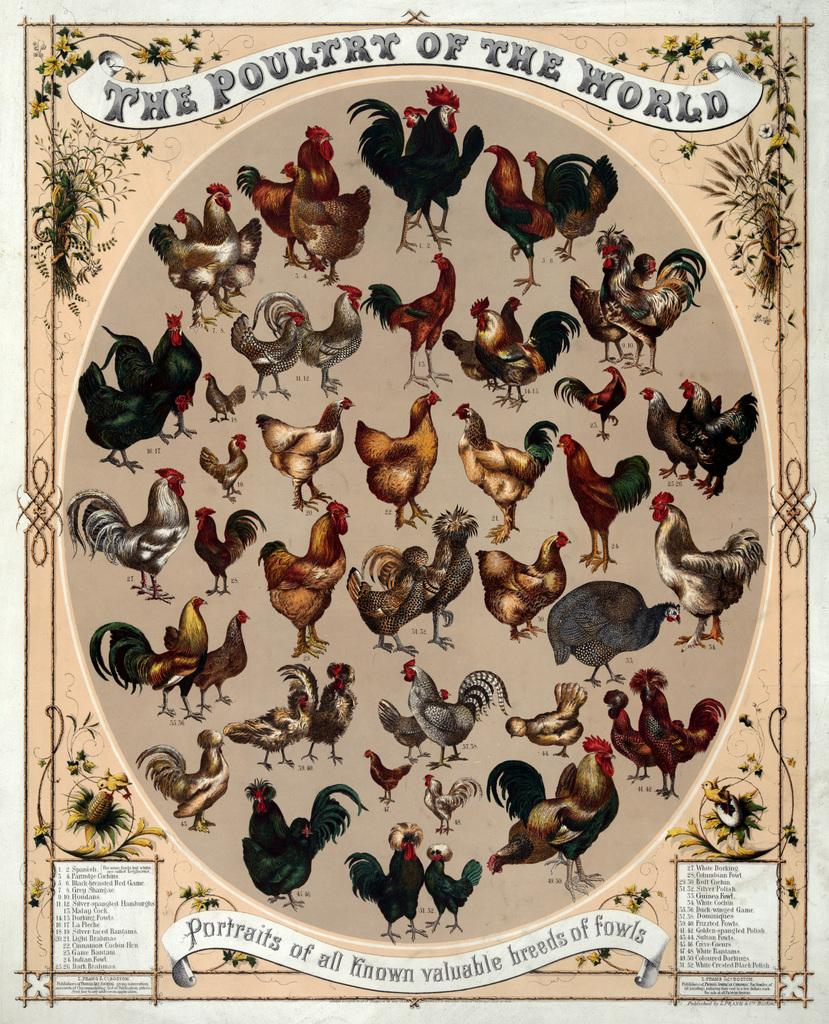What is present in the image that features images? There is a poster in the image. What type of animals are depicted on the poster? The poster contains pictures of hens. Can you see a swing in the image? There is no swing present in the image. Is there any water visible in the image? There is no water visible in the image. Can you see any airborne objects in the image? There is no specific mention of airborne objects in the provided facts, so we cannot definitively answer this question based on the given information. 